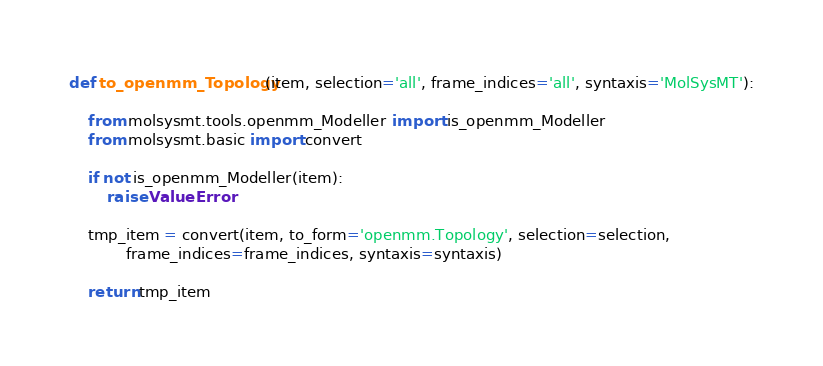Convert code to text. <code><loc_0><loc_0><loc_500><loc_500><_Python_>def to_openmm_Topology(item, selection='all', frame_indices='all', syntaxis='MolSysMT'):

    from molsysmt.tools.openmm_Modeller import is_openmm_Modeller
    from molsysmt.basic import convert

    if not is_openmm_Modeller(item):
        raise ValueError

    tmp_item = convert(item, to_form='openmm.Topology', selection=selection,
            frame_indices=frame_indices, syntaxis=syntaxis)

    return tmp_item

</code> 